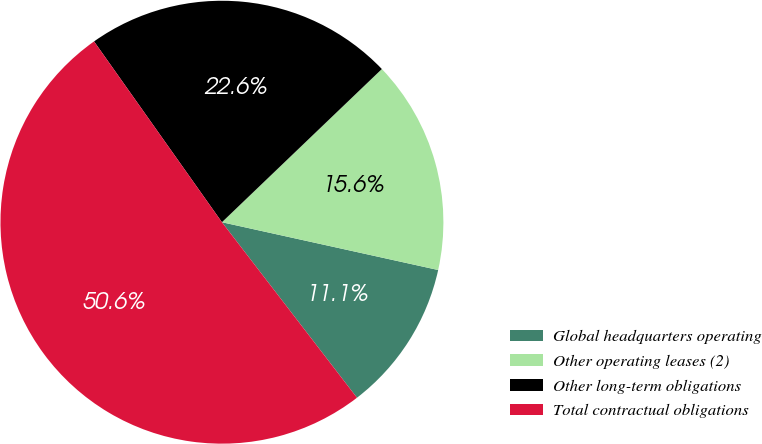Convert chart. <chart><loc_0><loc_0><loc_500><loc_500><pie_chart><fcel>Global headquarters operating<fcel>Other operating leases (2)<fcel>Other long-term obligations<fcel>Total contractual obligations<nl><fcel>11.1%<fcel>15.62%<fcel>22.64%<fcel>50.64%<nl></chart> 